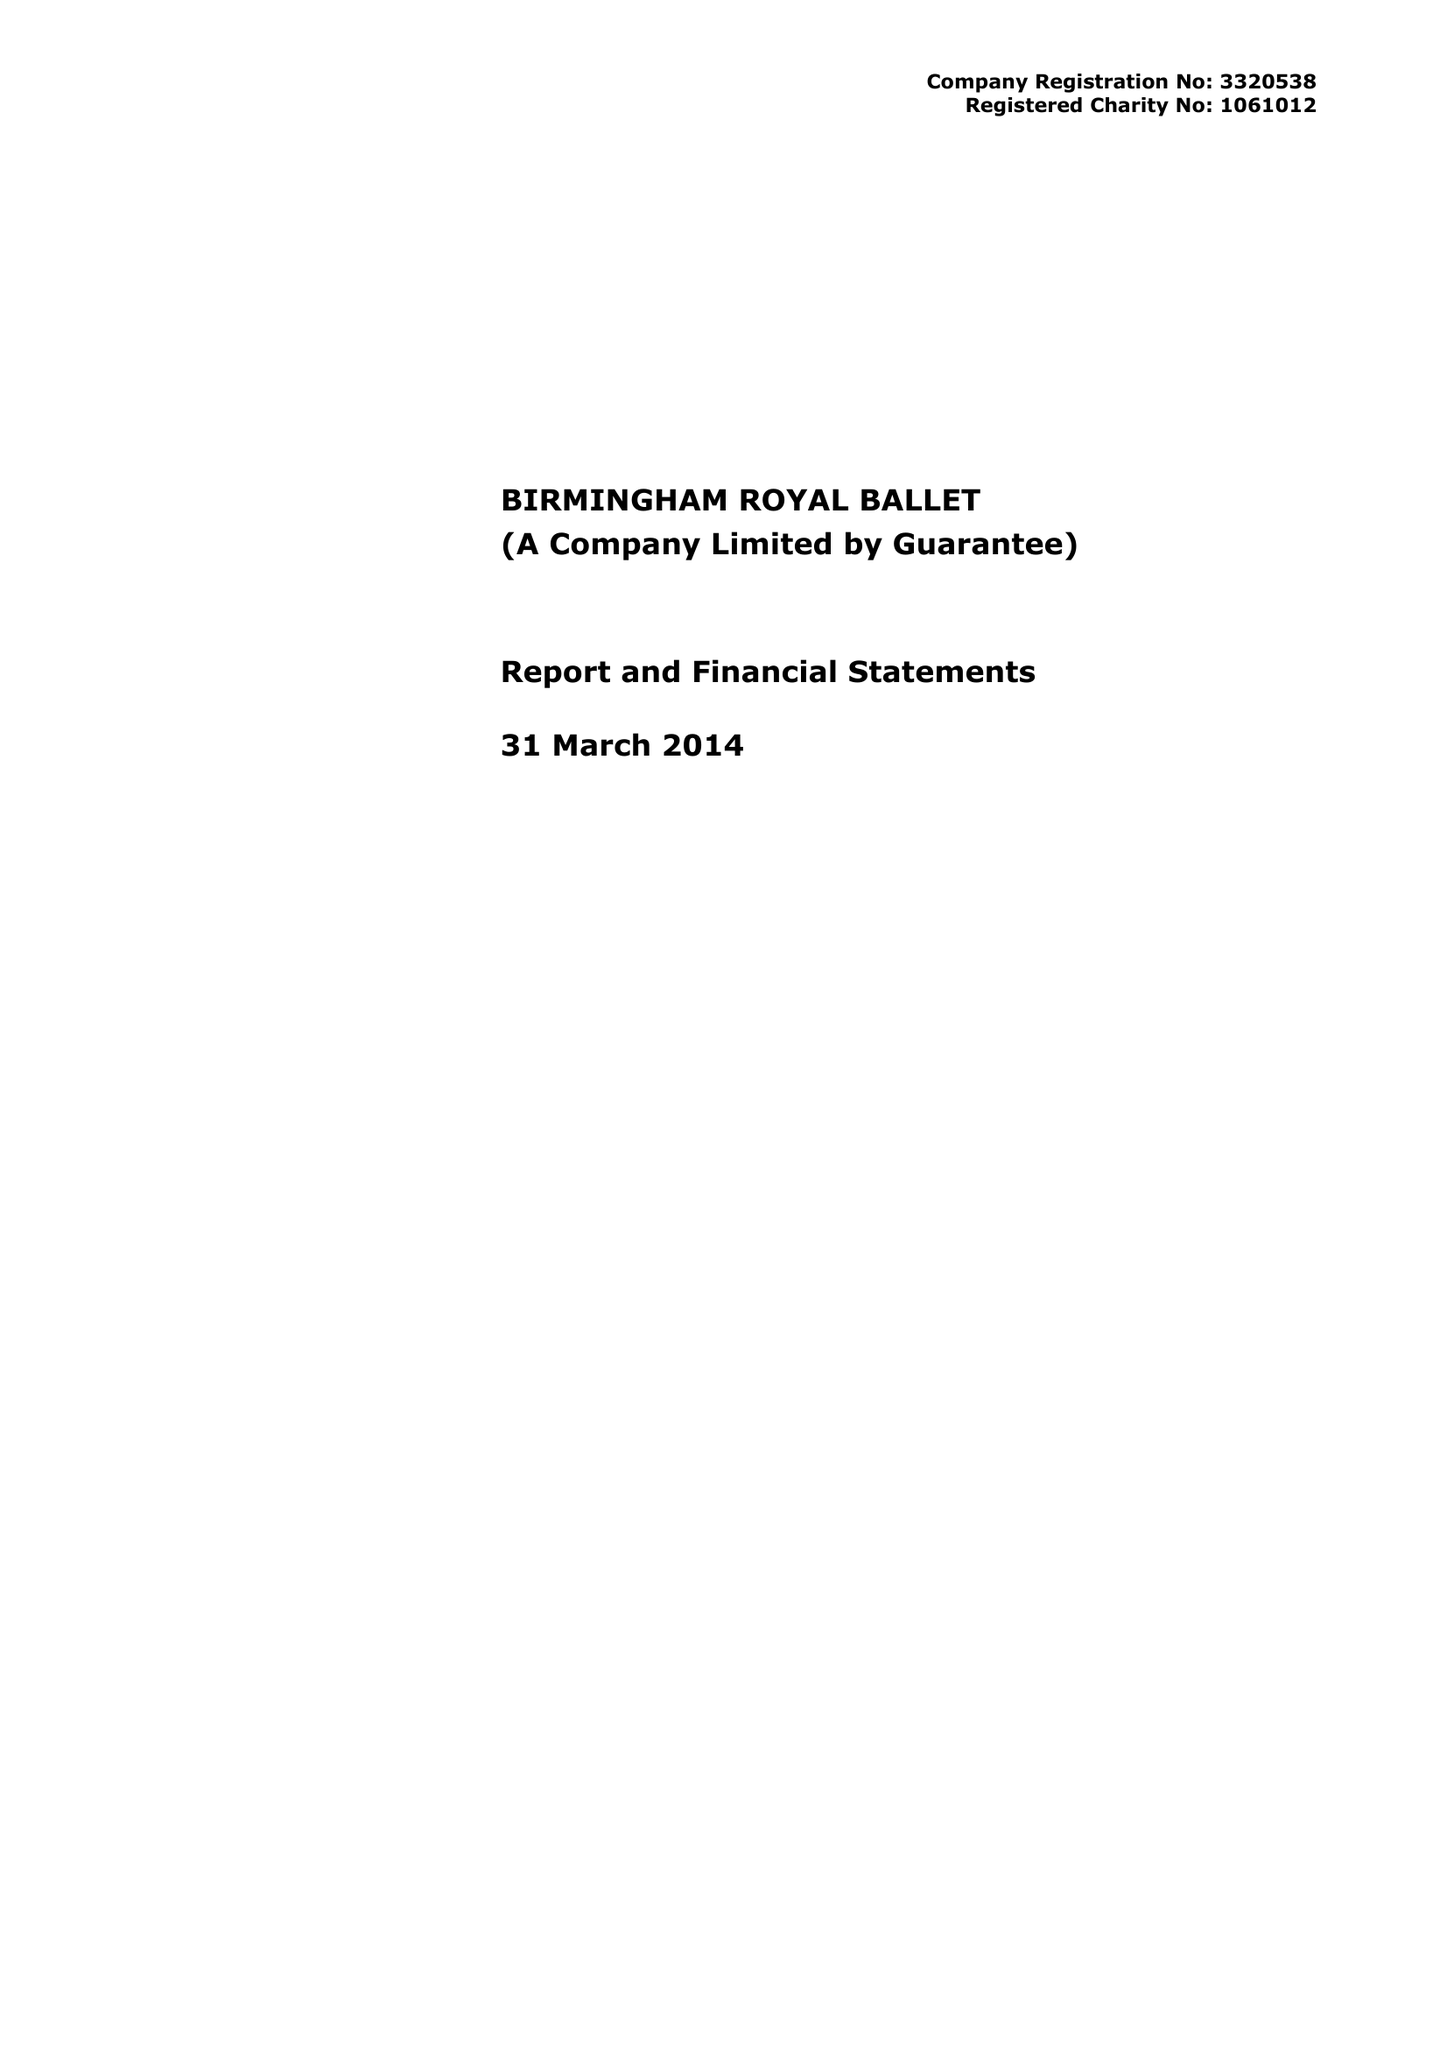What is the value for the address__post_town?
Answer the question using a single word or phrase. BIRMINGHAM 